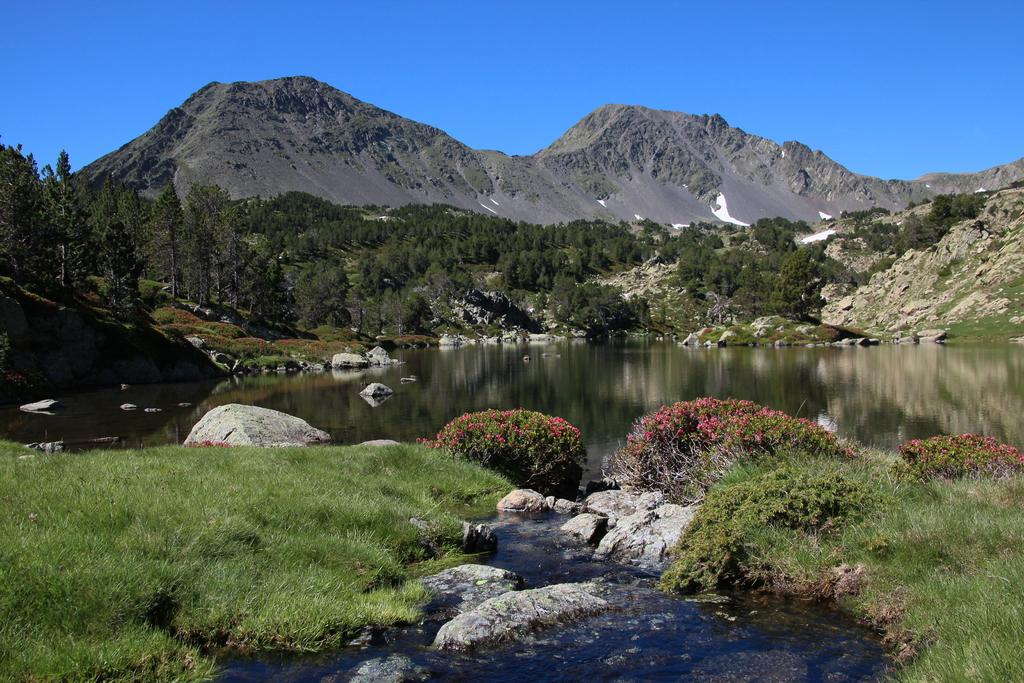What type of natural feature is present in the image? There is a river in the image. What other natural elements can be seen in the image? There are rocks, grass, plants, trees, and mountains in the image. What is visible in the sky in the image? The sky is visible in the image. What type of watch can be seen on the stranger's wrist in the image? There is no stranger or watch present in the image. What is the phase of the moon in the image? There is no moon visible in the image. 